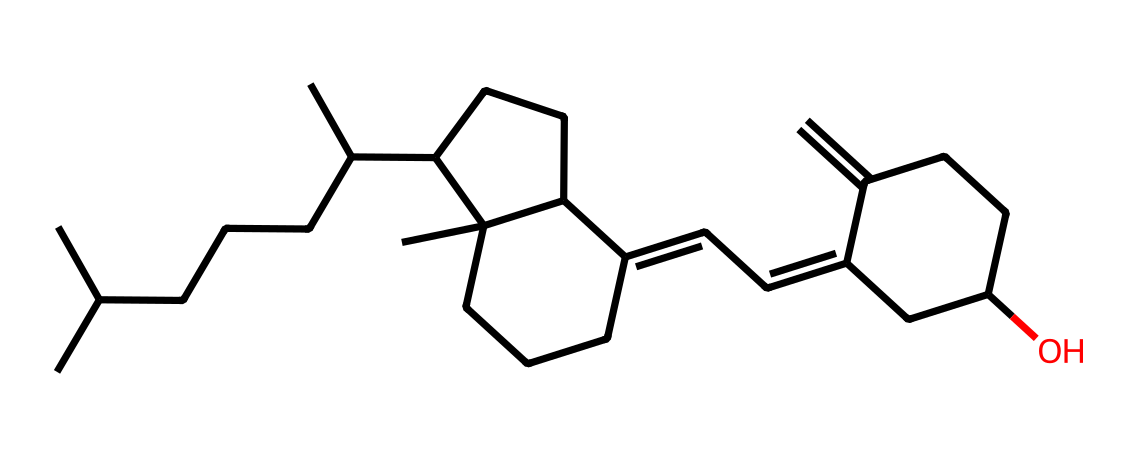What is the main functional group present in this vitamin D structure? The chemical structure primarily contains a steroid structure characterized by multiple rings. The presence of hydroxyl (-OH) group indicates that it is a vitamin D derivative.
Answer: hydroxyl group How many carbon atoms are present in the chemical structure of vitamin D? By analyzing the structure and counting the carbon atoms visually, there are a total of 27 carbon atoms depicted in the structural formula.
Answer: 27 What type of isomerism is likely present in vitamin D? Vitamin D can exhibit geometric isomerism due to the presence of C=C double bonds, where different spatial arrangements exist for the substituents connected to the double-bonded carbon atoms.
Answer: geometric isomerism What is the role of vitamin D in mood regulation? Vitamin D is believed to influence mood by regulating neurotransmitters like serotonin, and its deficiency is associated with mood disorders.
Answer: regulates serotonin How many rings does the vitamin D structure contain? By closely examining the structure, it is noted that there are four interconnected rings present in the steroid backbone of vitamin D.
Answer: four rings What type of vitamin is represented by this structure? The structure given represents vitamin D, which is classified as a fat-soluble vitamin crucial for calcium metabolism and bone health, among other functions.
Answer: fat-soluble vitamin What health issues can arise from a deficiency in vitamin D? A deficiency in vitamin D can lead to health issues such as osteoporosis, mood disorders, and impaired immune function, which are critical for overall health.
Answer: osteoporosis 